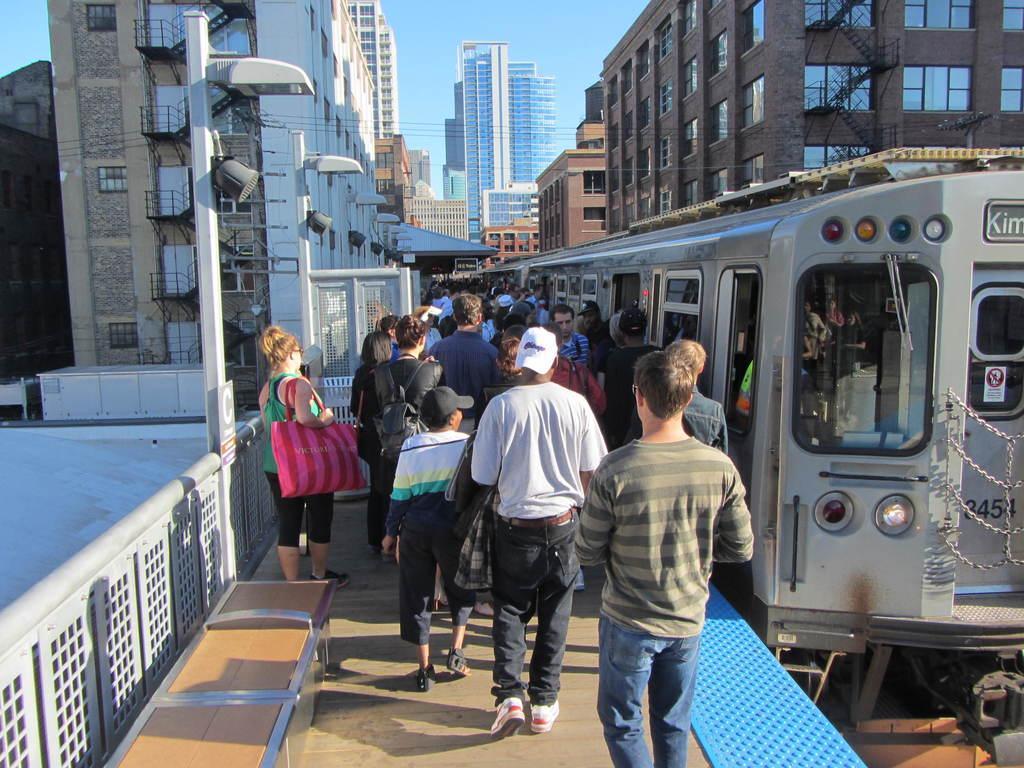Can you describe this image briefly? In this image we can see a train on the track. Here we can see a group of people on the platform. Here we can see a wooden bench on the platform and it is on the bottom left side. Here we can see the light poles. Here we can see the electric wires. Here we can see an electric pole on the top right side. In the background, we can see the buildings and here we can see the glass windows. 